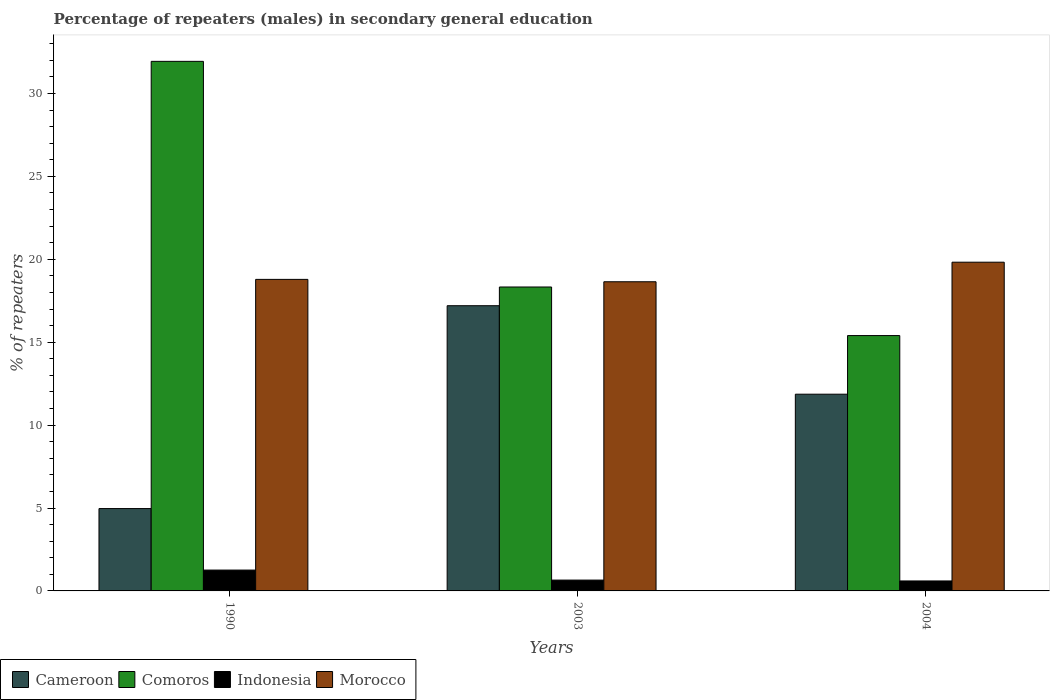How many groups of bars are there?
Give a very brief answer. 3. How many bars are there on the 3rd tick from the right?
Your answer should be very brief. 4. In how many cases, is the number of bars for a given year not equal to the number of legend labels?
Your answer should be very brief. 0. What is the percentage of male repeaters in Cameroon in 1990?
Provide a succinct answer. 4.97. Across all years, what is the maximum percentage of male repeaters in Cameroon?
Provide a short and direct response. 17.2. Across all years, what is the minimum percentage of male repeaters in Cameroon?
Your response must be concise. 4.97. What is the total percentage of male repeaters in Cameroon in the graph?
Offer a terse response. 34.03. What is the difference between the percentage of male repeaters in Comoros in 2003 and that in 2004?
Keep it short and to the point. 2.93. What is the difference between the percentage of male repeaters in Cameroon in 2003 and the percentage of male repeaters in Indonesia in 2004?
Ensure brevity in your answer.  16.6. What is the average percentage of male repeaters in Morocco per year?
Offer a very short reply. 19.09. In the year 1990, what is the difference between the percentage of male repeaters in Indonesia and percentage of male repeaters in Morocco?
Your answer should be compact. -17.53. What is the ratio of the percentage of male repeaters in Morocco in 1990 to that in 2004?
Your answer should be compact. 0.95. What is the difference between the highest and the second highest percentage of male repeaters in Morocco?
Your answer should be compact. 1.04. What is the difference between the highest and the lowest percentage of male repeaters in Indonesia?
Your answer should be compact. 0.66. Is the sum of the percentage of male repeaters in Comoros in 1990 and 2003 greater than the maximum percentage of male repeaters in Indonesia across all years?
Provide a short and direct response. Yes. Is it the case that in every year, the sum of the percentage of male repeaters in Comoros and percentage of male repeaters in Morocco is greater than the sum of percentage of male repeaters in Indonesia and percentage of male repeaters in Cameroon?
Provide a succinct answer. No. What does the 3rd bar from the right in 1990 represents?
Provide a short and direct response. Comoros. Are all the bars in the graph horizontal?
Make the answer very short. No. Are the values on the major ticks of Y-axis written in scientific E-notation?
Offer a terse response. No. Does the graph contain any zero values?
Make the answer very short. No. Does the graph contain grids?
Offer a terse response. No. How many legend labels are there?
Ensure brevity in your answer.  4. How are the legend labels stacked?
Offer a terse response. Horizontal. What is the title of the graph?
Provide a short and direct response. Percentage of repeaters (males) in secondary general education. What is the label or title of the Y-axis?
Offer a terse response. % of repeaters. What is the % of repeaters of Cameroon in 1990?
Your answer should be very brief. 4.97. What is the % of repeaters in Comoros in 1990?
Your answer should be compact. 31.94. What is the % of repeaters in Indonesia in 1990?
Offer a terse response. 1.26. What is the % of repeaters in Morocco in 1990?
Ensure brevity in your answer.  18.79. What is the % of repeaters in Cameroon in 2003?
Provide a short and direct response. 17.2. What is the % of repeaters in Comoros in 2003?
Provide a short and direct response. 18.33. What is the % of repeaters of Indonesia in 2003?
Give a very brief answer. 0.65. What is the % of repeaters in Morocco in 2003?
Your answer should be very brief. 18.64. What is the % of repeaters in Cameroon in 2004?
Your response must be concise. 11.86. What is the % of repeaters in Comoros in 2004?
Give a very brief answer. 15.4. What is the % of repeaters of Indonesia in 2004?
Offer a terse response. 0.6. What is the % of repeaters of Morocco in 2004?
Offer a very short reply. 19.82. Across all years, what is the maximum % of repeaters in Cameroon?
Keep it short and to the point. 17.2. Across all years, what is the maximum % of repeaters in Comoros?
Provide a succinct answer. 31.94. Across all years, what is the maximum % of repeaters in Indonesia?
Make the answer very short. 1.26. Across all years, what is the maximum % of repeaters in Morocco?
Your answer should be compact. 19.82. Across all years, what is the minimum % of repeaters of Cameroon?
Offer a terse response. 4.97. Across all years, what is the minimum % of repeaters in Comoros?
Keep it short and to the point. 15.4. Across all years, what is the minimum % of repeaters in Indonesia?
Provide a succinct answer. 0.6. Across all years, what is the minimum % of repeaters in Morocco?
Make the answer very short. 18.64. What is the total % of repeaters in Cameroon in the graph?
Provide a succinct answer. 34.03. What is the total % of repeaters in Comoros in the graph?
Give a very brief answer. 65.66. What is the total % of repeaters of Indonesia in the graph?
Offer a very short reply. 2.51. What is the total % of repeaters in Morocco in the graph?
Keep it short and to the point. 57.26. What is the difference between the % of repeaters in Cameroon in 1990 and that in 2003?
Offer a terse response. -12.23. What is the difference between the % of repeaters of Comoros in 1990 and that in 2003?
Ensure brevity in your answer.  13.61. What is the difference between the % of repeaters of Indonesia in 1990 and that in 2003?
Offer a very short reply. 0.6. What is the difference between the % of repeaters of Morocco in 1990 and that in 2003?
Offer a very short reply. 0.14. What is the difference between the % of repeaters of Cameroon in 1990 and that in 2004?
Offer a terse response. -6.9. What is the difference between the % of repeaters in Comoros in 1990 and that in 2004?
Give a very brief answer. 16.54. What is the difference between the % of repeaters in Indonesia in 1990 and that in 2004?
Provide a short and direct response. 0.66. What is the difference between the % of repeaters of Morocco in 1990 and that in 2004?
Give a very brief answer. -1.04. What is the difference between the % of repeaters in Cameroon in 2003 and that in 2004?
Offer a very short reply. 5.34. What is the difference between the % of repeaters of Comoros in 2003 and that in 2004?
Give a very brief answer. 2.93. What is the difference between the % of repeaters in Indonesia in 2003 and that in 2004?
Give a very brief answer. 0.05. What is the difference between the % of repeaters in Morocco in 2003 and that in 2004?
Provide a succinct answer. -1.18. What is the difference between the % of repeaters of Cameroon in 1990 and the % of repeaters of Comoros in 2003?
Your answer should be compact. -13.36. What is the difference between the % of repeaters in Cameroon in 1990 and the % of repeaters in Indonesia in 2003?
Provide a short and direct response. 4.31. What is the difference between the % of repeaters of Cameroon in 1990 and the % of repeaters of Morocco in 2003?
Provide a succinct answer. -13.68. What is the difference between the % of repeaters of Comoros in 1990 and the % of repeaters of Indonesia in 2003?
Provide a succinct answer. 31.28. What is the difference between the % of repeaters in Comoros in 1990 and the % of repeaters in Morocco in 2003?
Your response must be concise. 13.29. What is the difference between the % of repeaters of Indonesia in 1990 and the % of repeaters of Morocco in 2003?
Make the answer very short. -17.39. What is the difference between the % of repeaters in Cameroon in 1990 and the % of repeaters in Comoros in 2004?
Offer a terse response. -10.43. What is the difference between the % of repeaters of Cameroon in 1990 and the % of repeaters of Indonesia in 2004?
Offer a very short reply. 4.36. What is the difference between the % of repeaters of Cameroon in 1990 and the % of repeaters of Morocco in 2004?
Keep it short and to the point. -14.86. What is the difference between the % of repeaters in Comoros in 1990 and the % of repeaters in Indonesia in 2004?
Provide a short and direct response. 31.33. What is the difference between the % of repeaters of Comoros in 1990 and the % of repeaters of Morocco in 2004?
Offer a very short reply. 12.11. What is the difference between the % of repeaters in Indonesia in 1990 and the % of repeaters in Morocco in 2004?
Offer a very short reply. -18.57. What is the difference between the % of repeaters of Cameroon in 2003 and the % of repeaters of Comoros in 2004?
Give a very brief answer. 1.8. What is the difference between the % of repeaters of Cameroon in 2003 and the % of repeaters of Indonesia in 2004?
Your response must be concise. 16.6. What is the difference between the % of repeaters in Cameroon in 2003 and the % of repeaters in Morocco in 2004?
Keep it short and to the point. -2.62. What is the difference between the % of repeaters of Comoros in 2003 and the % of repeaters of Indonesia in 2004?
Give a very brief answer. 17.73. What is the difference between the % of repeaters of Comoros in 2003 and the % of repeaters of Morocco in 2004?
Keep it short and to the point. -1.5. What is the difference between the % of repeaters in Indonesia in 2003 and the % of repeaters in Morocco in 2004?
Provide a succinct answer. -19.17. What is the average % of repeaters in Cameroon per year?
Give a very brief answer. 11.34. What is the average % of repeaters of Comoros per year?
Your response must be concise. 21.89. What is the average % of repeaters in Indonesia per year?
Give a very brief answer. 0.84. What is the average % of repeaters in Morocco per year?
Your answer should be very brief. 19.09. In the year 1990, what is the difference between the % of repeaters in Cameroon and % of repeaters in Comoros?
Offer a very short reply. -26.97. In the year 1990, what is the difference between the % of repeaters of Cameroon and % of repeaters of Indonesia?
Provide a succinct answer. 3.71. In the year 1990, what is the difference between the % of repeaters in Cameroon and % of repeaters in Morocco?
Ensure brevity in your answer.  -13.82. In the year 1990, what is the difference between the % of repeaters in Comoros and % of repeaters in Indonesia?
Your answer should be very brief. 30.68. In the year 1990, what is the difference between the % of repeaters in Comoros and % of repeaters in Morocco?
Your answer should be very brief. 13.15. In the year 1990, what is the difference between the % of repeaters in Indonesia and % of repeaters in Morocco?
Offer a very short reply. -17.53. In the year 2003, what is the difference between the % of repeaters in Cameroon and % of repeaters in Comoros?
Provide a short and direct response. -1.13. In the year 2003, what is the difference between the % of repeaters in Cameroon and % of repeaters in Indonesia?
Provide a succinct answer. 16.55. In the year 2003, what is the difference between the % of repeaters of Cameroon and % of repeaters of Morocco?
Your answer should be compact. -1.44. In the year 2003, what is the difference between the % of repeaters in Comoros and % of repeaters in Indonesia?
Keep it short and to the point. 17.67. In the year 2003, what is the difference between the % of repeaters of Comoros and % of repeaters of Morocco?
Provide a succinct answer. -0.32. In the year 2003, what is the difference between the % of repeaters of Indonesia and % of repeaters of Morocco?
Your response must be concise. -17.99. In the year 2004, what is the difference between the % of repeaters of Cameroon and % of repeaters of Comoros?
Your answer should be compact. -3.54. In the year 2004, what is the difference between the % of repeaters of Cameroon and % of repeaters of Indonesia?
Your answer should be compact. 11.26. In the year 2004, what is the difference between the % of repeaters in Cameroon and % of repeaters in Morocco?
Your answer should be compact. -7.96. In the year 2004, what is the difference between the % of repeaters in Comoros and % of repeaters in Indonesia?
Your response must be concise. 14.8. In the year 2004, what is the difference between the % of repeaters of Comoros and % of repeaters of Morocco?
Make the answer very short. -4.42. In the year 2004, what is the difference between the % of repeaters in Indonesia and % of repeaters in Morocco?
Your response must be concise. -19.22. What is the ratio of the % of repeaters of Cameroon in 1990 to that in 2003?
Ensure brevity in your answer.  0.29. What is the ratio of the % of repeaters in Comoros in 1990 to that in 2003?
Give a very brief answer. 1.74. What is the ratio of the % of repeaters of Indonesia in 1990 to that in 2003?
Keep it short and to the point. 1.92. What is the ratio of the % of repeaters in Morocco in 1990 to that in 2003?
Ensure brevity in your answer.  1.01. What is the ratio of the % of repeaters of Cameroon in 1990 to that in 2004?
Make the answer very short. 0.42. What is the ratio of the % of repeaters in Comoros in 1990 to that in 2004?
Offer a very short reply. 2.07. What is the ratio of the % of repeaters in Indonesia in 1990 to that in 2004?
Keep it short and to the point. 2.09. What is the ratio of the % of repeaters of Morocco in 1990 to that in 2004?
Your answer should be compact. 0.95. What is the ratio of the % of repeaters in Cameroon in 2003 to that in 2004?
Your answer should be very brief. 1.45. What is the ratio of the % of repeaters of Comoros in 2003 to that in 2004?
Offer a terse response. 1.19. What is the ratio of the % of repeaters in Indonesia in 2003 to that in 2004?
Your answer should be compact. 1.09. What is the ratio of the % of repeaters of Morocco in 2003 to that in 2004?
Give a very brief answer. 0.94. What is the difference between the highest and the second highest % of repeaters in Cameroon?
Offer a terse response. 5.34. What is the difference between the highest and the second highest % of repeaters of Comoros?
Offer a very short reply. 13.61. What is the difference between the highest and the second highest % of repeaters in Indonesia?
Offer a very short reply. 0.6. What is the difference between the highest and the second highest % of repeaters of Morocco?
Your answer should be compact. 1.04. What is the difference between the highest and the lowest % of repeaters of Cameroon?
Your answer should be very brief. 12.23. What is the difference between the highest and the lowest % of repeaters of Comoros?
Keep it short and to the point. 16.54. What is the difference between the highest and the lowest % of repeaters of Indonesia?
Your response must be concise. 0.66. What is the difference between the highest and the lowest % of repeaters in Morocco?
Your answer should be very brief. 1.18. 